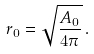Convert formula to latex. <formula><loc_0><loc_0><loc_500><loc_500>r _ { 0 } = \sqrt { \frac { A _ { 0 } } { 4 \pi } } \, .</formula> 